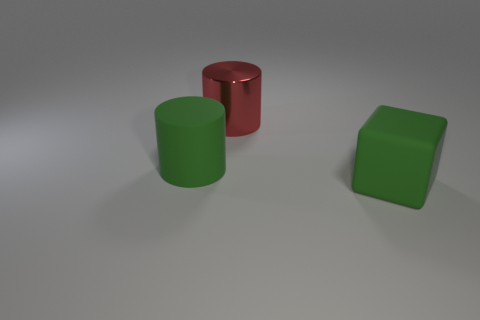Add 3 small gray metal cubes. How many objects exist? 6 Subtract all blocks. How many objects are left? 2 Subtract 0 cyan cylinders. How many objects are left? 3 Subtract all red cylinders. Subtract all green rubber objects. How many objects are left? 0 Add 2 rubber cubes. How many rubber cubes are left? 3 Add 2 rubber things. How many rubber things exist? 4 